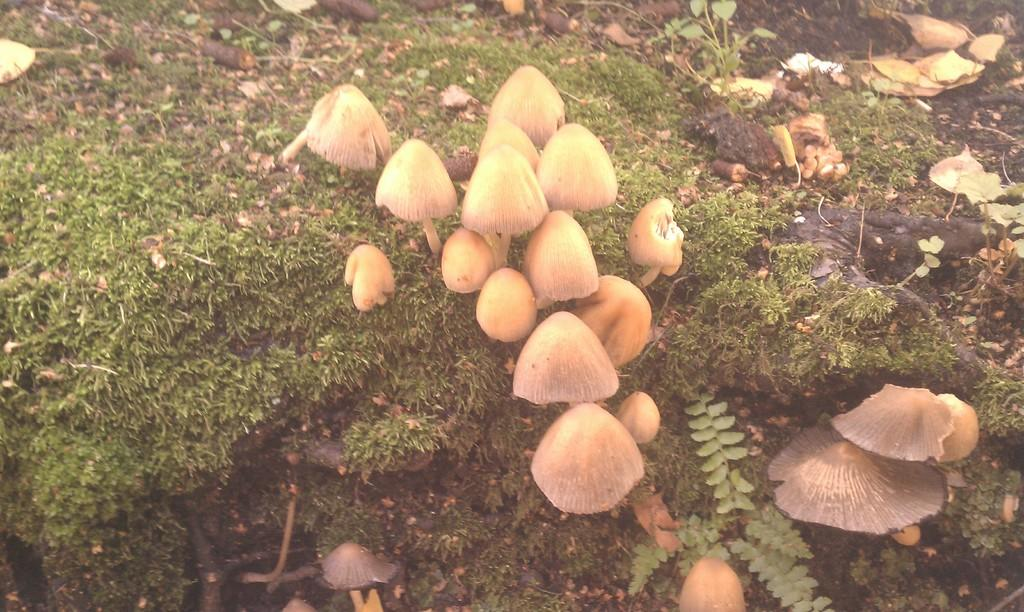What type of fungi can be seen in the image? There are mushrooms in the image. What type of vegetation is present in the image? There is grass and plants in the image. What type of animals can be seen in the zoo in the image? There is no zoo present in the image, and therefore no animals can be observed. Is there anyone driving a vehicle in the image? There is no vehicle or person driving in the image. 